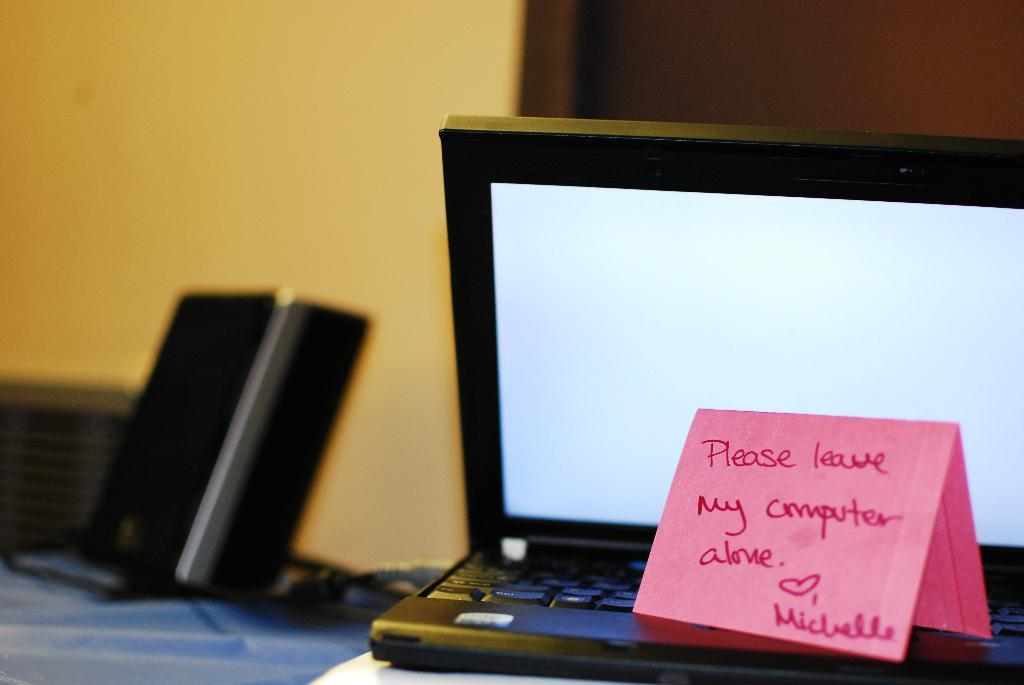<image>
Provide a brief description of the given image. A small notebook computer with a pink post it note that reads "please leave my computer alone". 